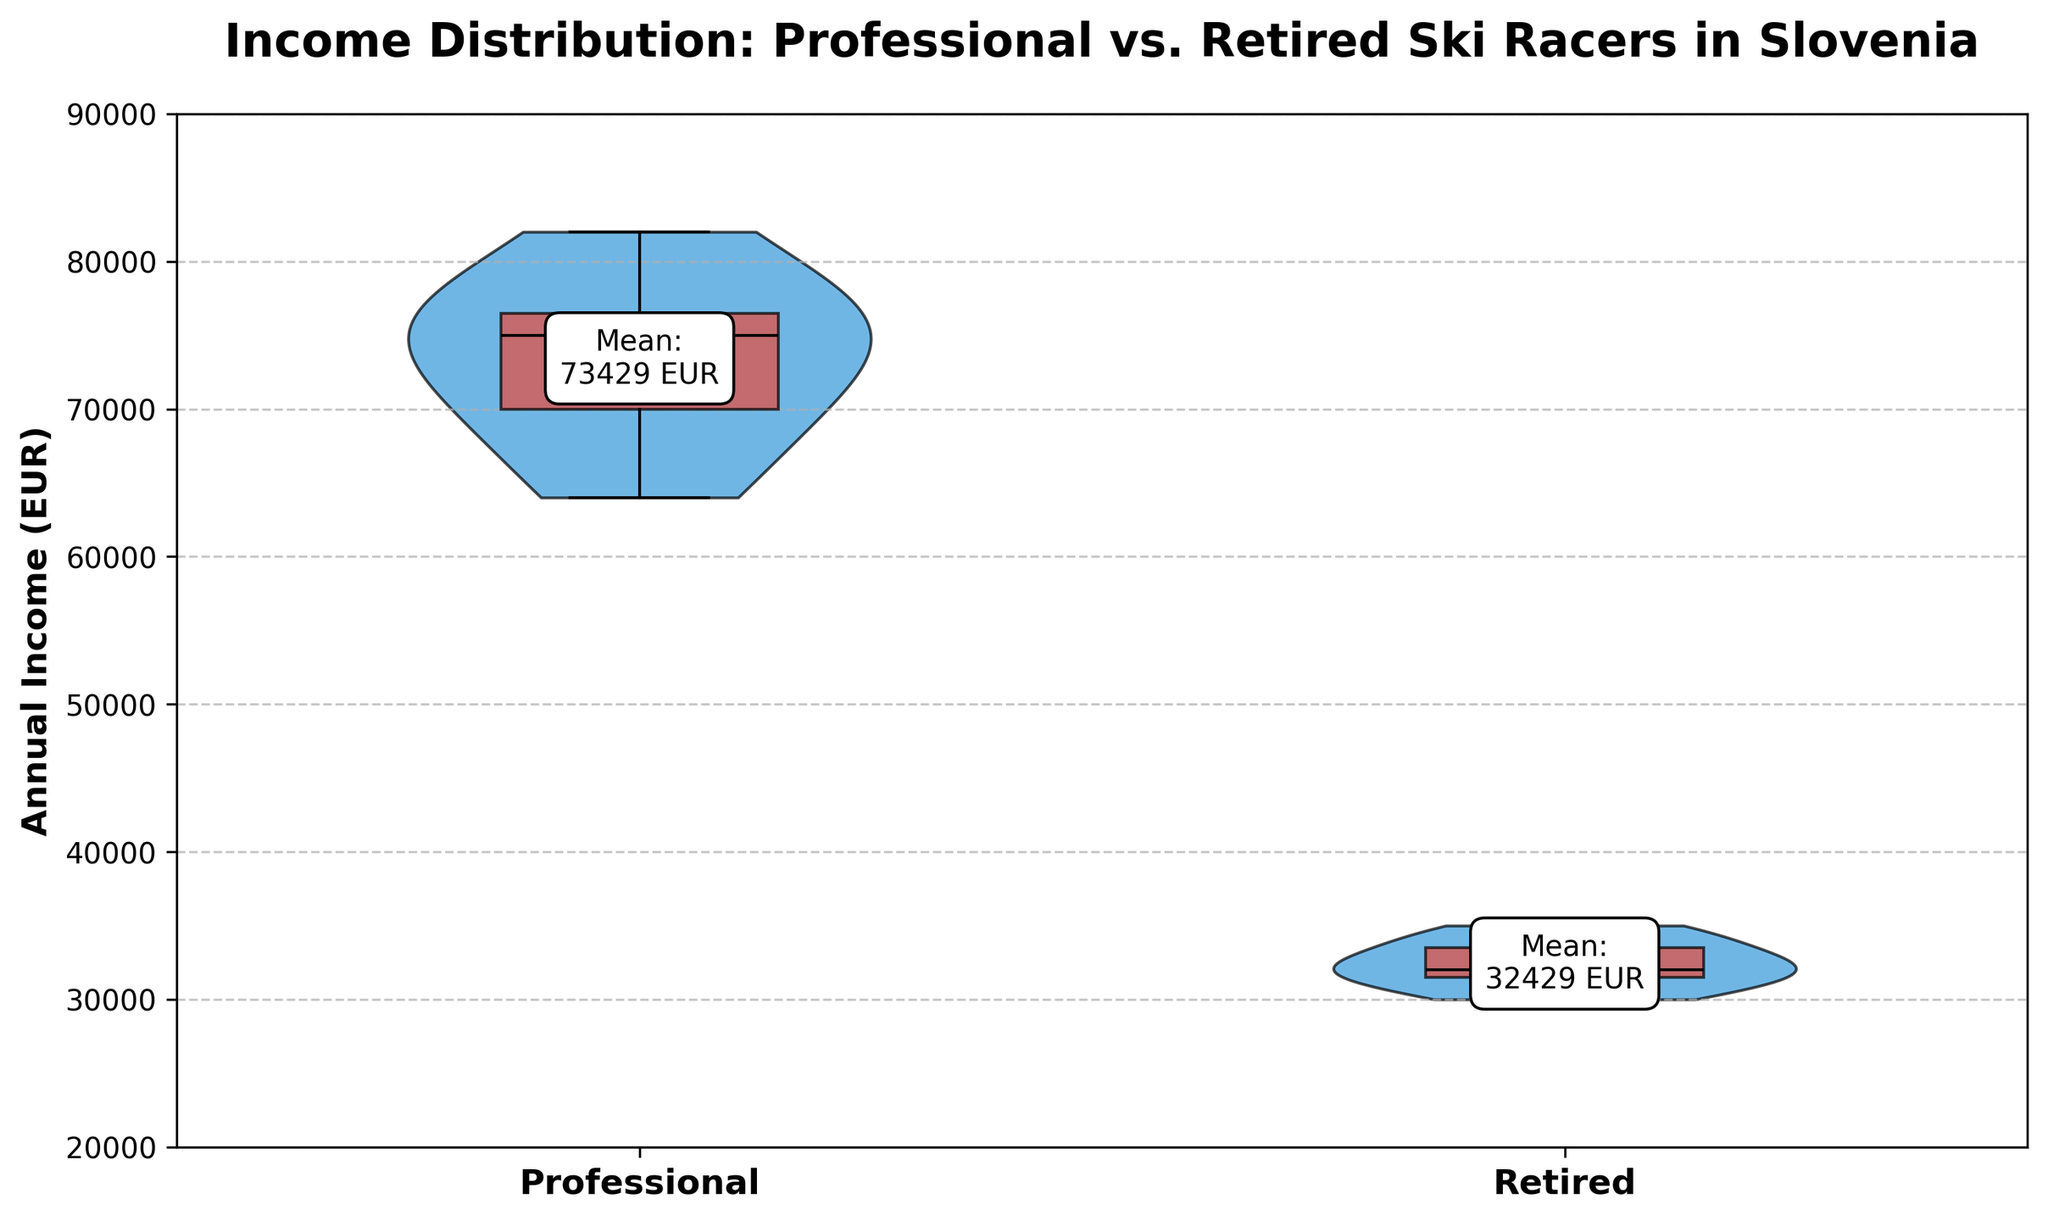What's the title of the figure? The title is at the top of the figure. It reads 'Income Distribution: Professional vs. Retired Ski Racers in Slovenia'.
Answer: Income Distribution: Professional vs. Retired Ski Racers in Slovenia What does the y-axis represent? The y-axis label indicates the metric being measured, which is 'Annual Income (EUR)'.
Answer: Annual Income (EUR) What are the groups being compared in the figure? The x-axis labels show two groups: 'Professional' and 'Retired'.
Answer: Professional and Retired What's the rough mean annual income of retired ski racers? The mean value for retired ski racers is visually annotated and reads approximately 32,000 EUR.
Answer: 32,000 EUR Which group has a higher median annual income? The boxplots inside the violin plots show where most data points cluster. The median is higher for the Professional group, which is visually higher on the plot.
Answer: Professional What is the approximate mean annual income difference between professional and retired ski racers? Mean values are annotated: Professional (73,429 EUR) and Retired (32,000 EUR). The difference is approximately 73,429 - 32,000 = 41,429 EUR.
Answer: 41,429 EUR Which group has a wider distribution of income? The width of the violins represents the distribution spread. The Professional violin is wider, indicating a wider income range.
Answer: Professional Is the annual income spread more even among retired ski racers? The retired group's violin shape is narrower and more symmetric compared to the professional group, indicating a more even spread.
Answer: Yes Is the highest observed income higher for professionals or retirees? The highest point on the professional group's boxplot is at a higher value (near upper limit around 82,000 EUR) compared to the retired group's boxplot.
Answer: Professionals How many groups show visually annotated mean values? There are two groups, Professional and Retired, each with a visually annotated mean value.
Answer: Two 